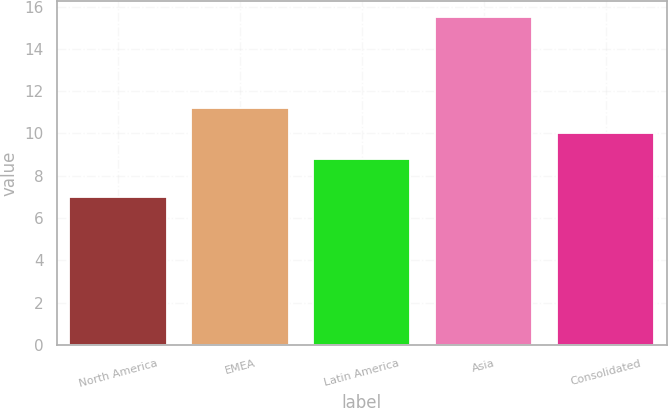<chart> <loc_0><loc_0><loc_500><loc_500><bar_chart><fcel>North America<fcel>EMEA<fcel>Latin America<fcel>Asia<fcel>Consolidated<nl><fcel>7<fcel>11.2<fcel>8.8<fcel>15.5<fcel>10<nl></chart> 